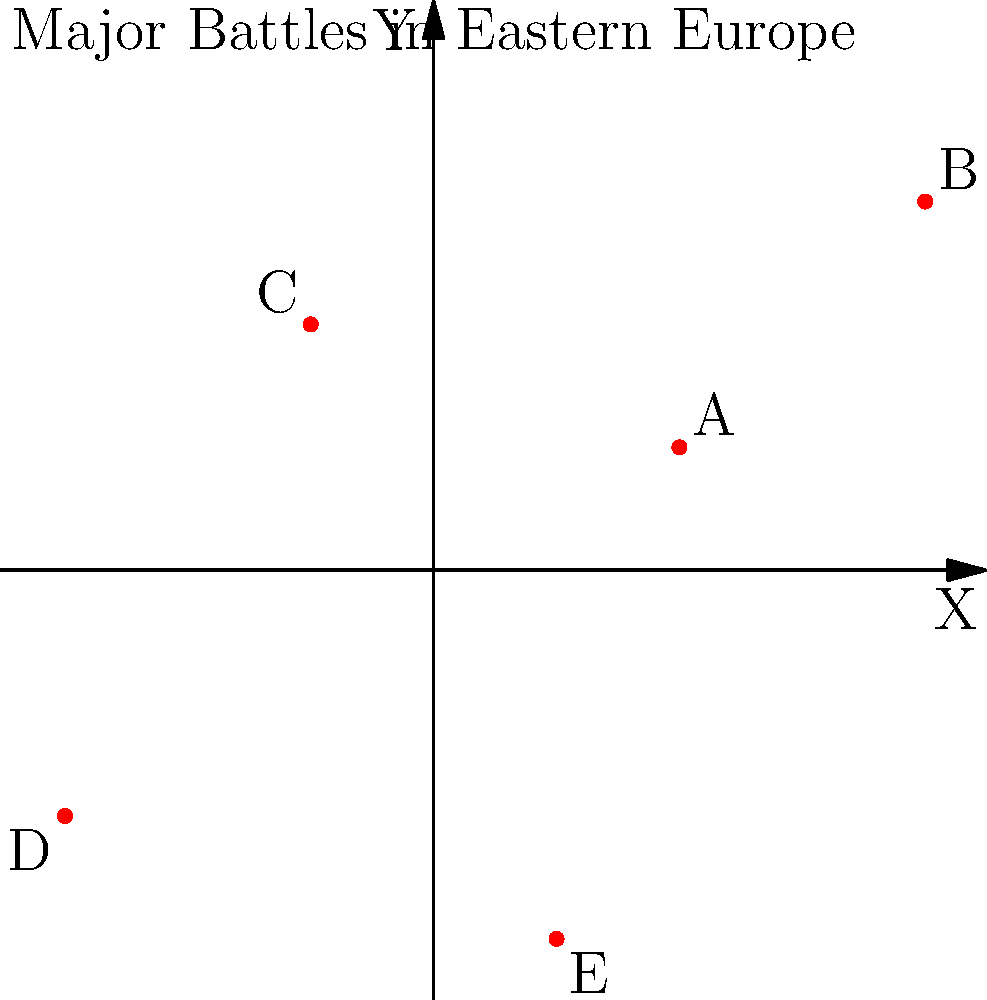On the coordinate plane representing a map of Eastern Europe, five major battles from World War II are plotted as points A, B, C, D, and E. If these points represent the battles of Stalingrad, Moscow, Kursk, Leningrad, and Kiev respectively, which battle took place at coordinates (4,3)? To answer this question, we need to analyze the given information and the coordinate plane:

1. We have five battles plotted on the coordinate plane: Stalingrad, Moscow, Kursk, Leningrad, and Kiev.
2. These battles are represented by points A, B, C, D, and E respectively.
3. We need to identify which point is located at coordinates (4,3).

Let's examine each point:
- Point A is at (2,1)
- Point B is at (4,3)
- Point C is at (-1,2)
- Point D is at (-3,-2)
- Point E is at (1,-3)

We can see that Point B is located at coordinates (4,3).

Now, we need to match Point B with its corresponding battle:
Point B represents the second battle in the list, which is Moscow.

Therefore, the battle that took place at coordinates (4,3) is the Battle of Moscow.
Answer: Moscow 